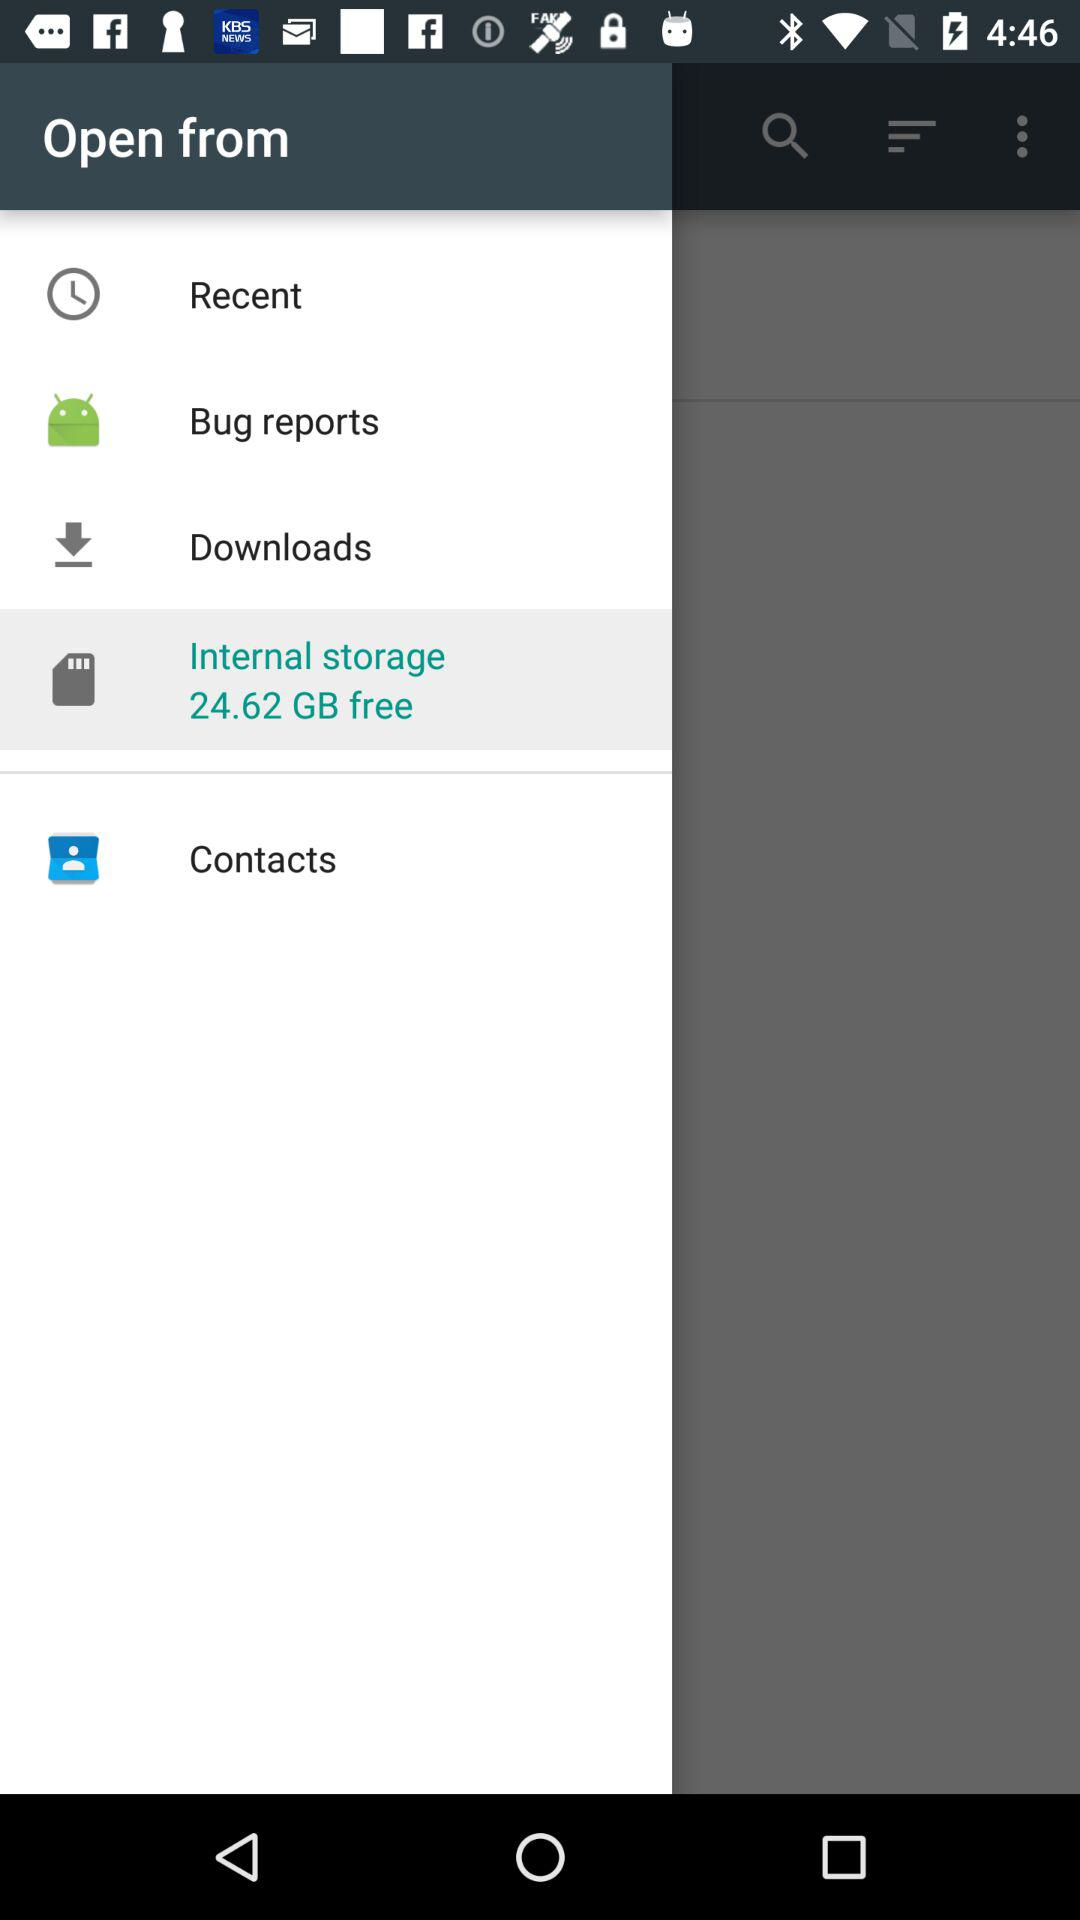What's the total free size of "Internal storage"? The total free size is 24.62 GB. 